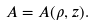Convert formula to latex. <formula><loc_0><loc_0><loc_500><loc_500>A = A ( \rho , z ) .</formula> 